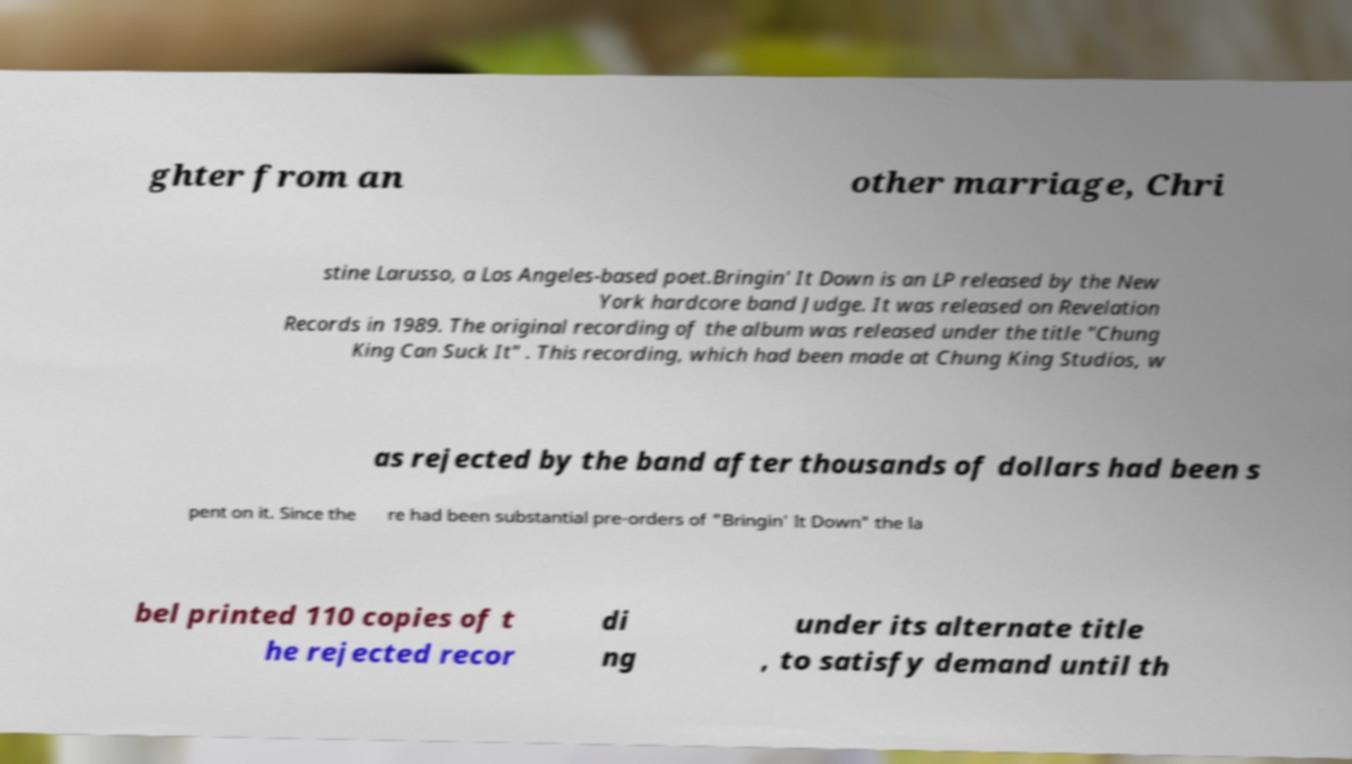What messages or text are displayed in this image? I need them in a readable, typed format. ghter from an other marriage, Chri stine Larusso, a Los Angeles-based poet.Bringin' It Down is an LP released by the New York hardcore band Judge. It was released on Revelation Records in 1989. The original recording of the album was released under the title "Chung King Can Suck It" . This recording, which had been made at Chung King Studios, w as rejected by the band after thousands of dollars had been s pent on it. Since the re had been substantial pre-orders of "Bringin' It Down" the la bel printed 110 copies of t he rejected recor di ng under its alternate title , to satisfy demand until th 